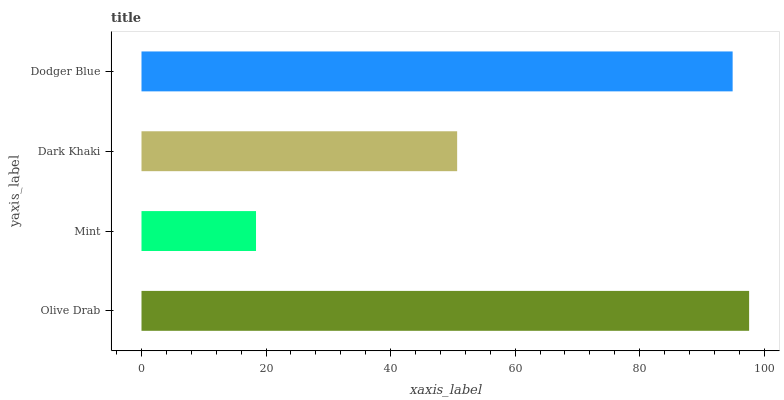Is Mint the minimum?
Answer yes or no. Yes. Is Olive Drab the maximum?
Answer yes or no. Yes. Is Dark Khaki the minimum?
Answer yes or no. No. Is Dark Khaki the maximum?
Answer yes or no. No. Is Dark Khaki greater than Mint?
Answer yes or no. Yes. Is Mint less than Dark Khaki?
Answer yes or no. Yes. Is Mint greater than Dark Khaki?
Answer yes or no. No. Is Dark Khaki less than Mint?
Answer yes or no. No. Is Dodger Blue the high median?
Answer yes or no. Yes. Is Dark Khaki the low median?
Answer yes or no. Yes. Is Olive Drab the high median?
Answer yes or no. No. Is Olive Drab the low median?
Answer yes or no. No. 